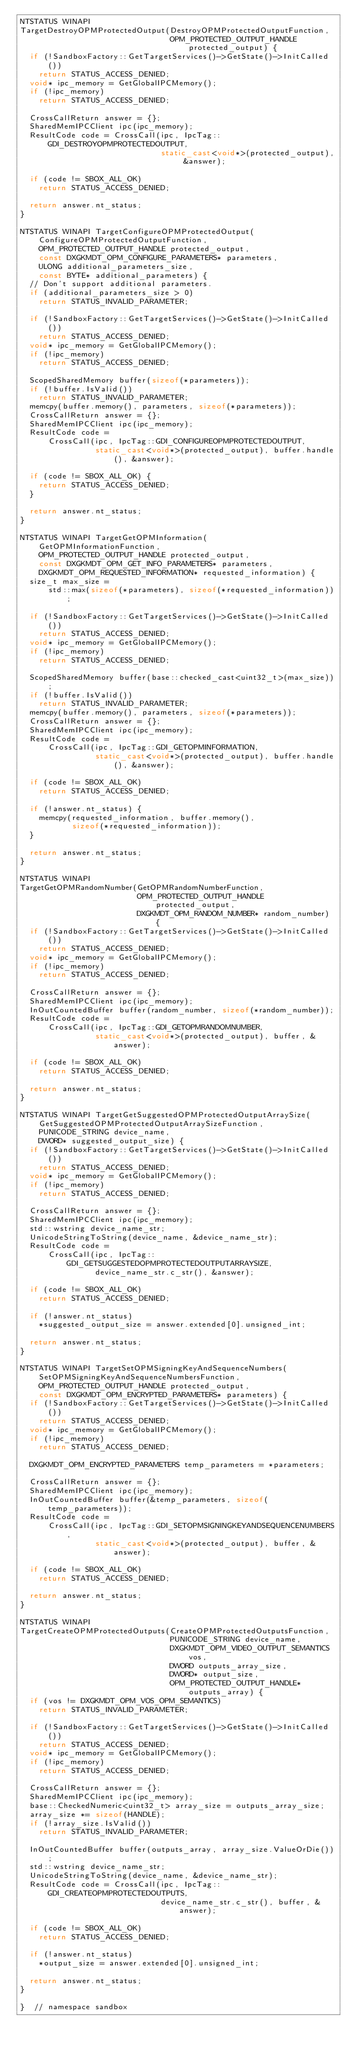<code> <loc_0><loc_0><loc_500><loc_500><_C++_>NTSTATUS WINAPI
TargetDestroyOPMProtectedOutput(DestroyOPMProtectedOutputFunction,
                                OPM_PROTECTED_OUTPUT_HANDLE protected_output) {
  if (!SandboxFactory::GetTargetServices()->GetState()->InitCalled())
    return STATUS_ACCESS_DENIED;
  void* ipc_memory = GetGlobalIPCMemory();
  if (!ipc_memory)
    return STATUS_ACCESS_DENIED;

  CrossCallReturn answer = {};
  SharedMemIPCClient ipc(ipc_memory);
  ResultCode code = CrossCall(ipc, IpcTag::GDI_DESTROYOPMPROTECTEDOUTPUT,
                              static_cast<void*>(protected_output), &answer);

  if (code != SBOX_ALL_OK)
    return STATUS_ACCESS_DENIED;

  return answer.nt_status;
}

NTSTATUS WINAPI TargetConfigureOPMProtectedOutput(
    ConfigureOPMProtectedOutputFunction,
    OPM_PROTECTED_OUTPUT_HANDLE protected_output,
    const DXGKMDT_OPM_CONFIGURE_PARAMETERS* parameters,
    ULONG additional_parameters_size,
    const BYTE* additional_parameters) {
  // Don't support additional parameters.
  if (additional_parameters_size > 0)
    return STATUS_INVALID_PARAMETER;

  if (!SandboxFactory::GetTargetServices()->GetState()->InitCalled())
    return STATUS_ACCESS_DENIED;
  void* ipc_memory = GetGlobalIPCMemory();
  if (!ipc_memory)
    return STATUS_ACCESS_DENIED;

  ScopedSharedMemory buffer(sizeof(*parameters));
  if (!buffer.IsValid())
    return STATUS_INVALID_PARAMETER;
  memcpy(buffer.memory(), parameters, sizeof(*parameters));
  CrossCallReturn answer = {};
  SharedMemIPCClient ipc(ipc_memory);
  ResultCode code =
      CrossCall(ipc, IpcTag::GDI_CONFIGUREOPMPROTECTEDOUTPUT,
                static_cast<void*>(protected_output), buffer.handle(), &answer);

  if (code != SBOX_ALL_OK) {
    return STATUS_ACCESS_DENIED;
  }

  return answer.nt_status;
}

NTSTATUS WINAPI TargetGetOPMInformation(
    GetOPMInformationFunction,
    OPM_PROTECTED_OUTPUT_HANDLE protected_output,
    const DXGKMDT_OPM_GET_INFO_PARAMETERS* parameters,
    DXGKMDT_OPM_REQUESTED_INFORMATION* requested_information) {
  size_t max_size =
      std::max(sizeof(*parameters), sizeof(*requested_information));

  if (!SandboxFactory::GetTargetServices()->GetState()->InitCalled())
    return STATUS_ACCESS_DENIED;
  void* ipc_memory = GetGlobalIPCMemory();
  if (!ipc_memory)
    return STATUS_ACCESS_DENIED;

  ScopedSharedMemory buffer(base::checked_cast<uint32_t>(max_size));
  if (!buffer.IsValid())
    return STATUS_INVALID_PARAMETER;
  memcpy(buffer.memory(), parameters, sizeof(*parameters));
  CrossCallReturn answer = {};
  SharedMemIPCClient ipc(ipc_memory);
  ResultCode code =
      CrossCall(ipc, IpcTag::GDI_GETOPMINFORMATION,
                static_cast<void*>(protected_output), buffer.handle(), &answer);

  if (code != SBOX_ALL_OK)
    return STATUS_ACCESS_DENIED;

  if (!answer.nt_status) {
    memcpy(requested_information, buffer.memory(),
           sizeof(*requested_information));
  }

  return answer.nt_status;
}

NTSTATUS WINAPI
TargetGetOPMRandomNumber(GetOPMRandomNumberFunction,
                         OPM_PROTECTED_OUTPUT_HANDLE protected_output,
                         DXGKMDT_OPM_RANDOM_NUMBER* random_number) {
  if (!SandboxFactory::GetTargetServices()->GetState()->InitCalled())
    return STATUS_ACCESS_DENIED;
  void* ipc_memory = GetGlobalIPCMemory();
  if (!ipc_memory)
    return STATUS_ACCESS_DENIED;

  CrossCallReturn answer = {};
  SharedMemIPCClient ipc(ipc_memory);
  InOutCountedBuffer buffer(random_number, sizeof(*random_number));
  ResultCode code =
      CrossCall(ipc, IpcTag::GDI_GETOPMRANDOMNUMBER,
                static_cast<void*>(protected_output), buffer, &answer);

  if (code != SBOX_ALL_OK)
    return STATUS_ACCESS_DENIED;

  return answer.nt_status;
}

NTSTATUS WINAPI TargetGetSuggestedOPMProtectedOutputArraySize(
    GetSuggestedOPMProtectedOutputArraySizeFunction,
    PUNICODE_STRING device_name,
    DWORD* suggested_output_size) {
  if (!SandboxFactory::GetTargetServices()->GetState()->InitCalled())
    return STATUS_ACCESS_DENIED;
  void* ipc_memory = GetGlobalIPCMemory();
  if (!ipc_memory)
    return STATUS_ACCESS_DENIED;

  CrossCallReturn answer = {};
  SharedMemIPCClient ipc(ipc_memory);
  std::wstring device_name_str;
  UnicodeStringToString(device_name, &device_name_str);
  ResultCode code =
      CrossCall(ipc, IpcTag::GDI_GETSUGGESTEDOPMPROTECTEDOUTPUTARRAYSIZE,
                device_name_str.c_str(), &answer);

  if (code != SBOX_ALL_OK)
    return STATUS_ACCESS_DENIED;

  if (!answer.nt_status)
    *suggested_output_size = answer.extended[0].unsigned_int;

  return answer.nt_status;
}

NTSTATUS WINAPI TargetSetOPMSigningKeyAndSequenceNumbers(
    SetOPMSigningKeyAndSequenceNumbersFunction,
    OPM_PROTECTED_OUTPUT_HANDLE protected_output,
    const DXGKMDT_OPM_ENCRYPTED_PARAMETERS* parameters) {
  if (!SandboxFactory::GetTargetServices()->GetState()->InitCalled())
    return STATUS_ACCESS_DENIED;
  void* ipc_memory = GetGlobalIPCMemory();
  if (!ipc_memory)
    return STATUS_ACCESS_DENIED;

  DXGKMDT_OPM_ENCRYPTED_PARAMETERS temp_parameters = *parameters;

  CrossCallReturn answer = {};
  SharedMemIPCClient ipc(ipc_memory);
  InOutCountedBuffer buffer(&temp_parameters, sizeof(temp_parameters));
  ResultCode code =
      CrossCall(ipc, IpcTag::GDI_SETOPMSIGNINGKEYANDSEQUENCENUMBERS,
                static_cast<void*>(protected_output), buffer, &answer);

  if (code != SBOX_ALL_OK)
    return STATUS_ACCESS_DENIED;

  return answer.nt_status;
}

NTSTATUS WINAPI
TargetCreateOPMProtectedOutputs(CreateOPMProtectedOutputsFunction,
                                PUNICODE_STRING device_name,
                                DXGKMDT_OPM_VIDEO_OUTPUT_SEMANTICS vos,
                                DWORD outputs_array_size,
                                DWORD* output_size,
                                OPM_PROTECTED_OUTPUT_HANDLE* outputs_array) {
  if (vos != DXGKMDT_OPM_VOS_OPM_SEMANTICS)
    return STATUS_INVALID_PARAMETER;

  if (!SandboxFactory::GetTargetServices()->GetState()->InitCalled())
    return STATUS_ACCESS_DENIED;
  void* ipc_memory = GetGlobalIPCMemory();
  if (!ipc_memory)
    return STATUS_ACCESS_DENIED;

  CrossCallReturn answer = {};
  SharedMemIPCClient ipc(ipc_memory);
  base::CheckedNumeric<uint32_t> array_size = outputs_array_size;
  array_size *= sizeof(HANDLE);
  if (!array_size.IsValid())
    return STATUS_INVALID_PARAMETER;

  InOutCountedBuffer buffer(outputs_array, array_size.ValueOrDie());
  std::wstring device_name_str;
  UnicodeStringToString(device_name, &device_name_str);
  ResultCode code = CrossCall(ipc, IpcTag::GDI_CREATEOPMPROTECTEDOUTPUTS,
                              device_name_str.c_str(), buffer, &answer);

  if (code != SBOX_ALL_OK)
    return STATUS_ACCESS_DENIED;

  if (!answer.nt_status)
    *output_size = answer.extended[0].unsigned_int;

  return answer.nt_status;
}

}  // namespace sandbox
</code> 